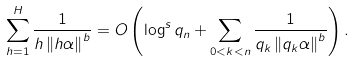<formula> <loc_0><loc_0><loc_500><loc_500>\sum _ { h = 1 } ^ { H } \frac { 1 } { h \left \| h \alpha \right \| ^ { b } } = O \left ( \log ^ { s } q _ { n } + \sum _ { 0 < k < n } \frac { 1 } { q _ { k } \left \| q _ { k } \alpha \right \| ^ { b } } \right ) .</formula> 